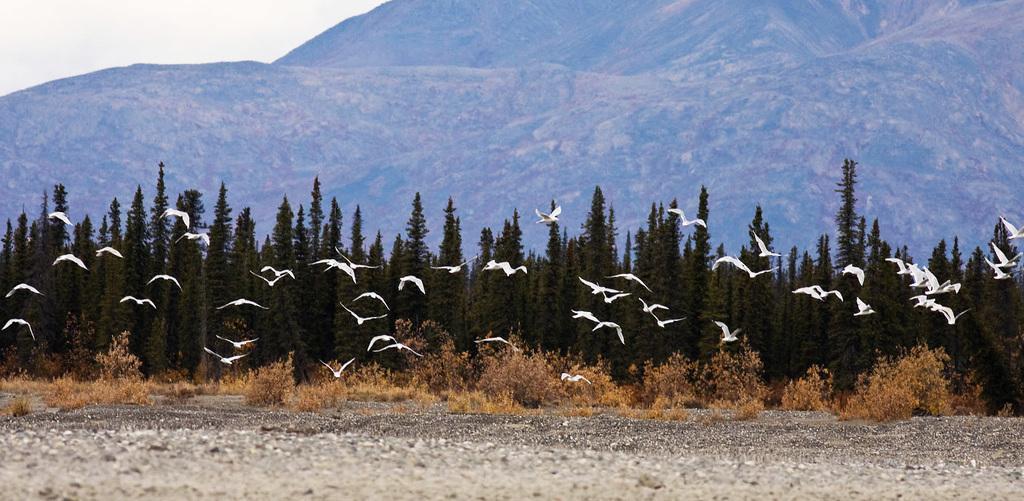Can you describe this image briefly? In this image we can see some birds are flying. In the background of the image there are trees, mountains and sky. 